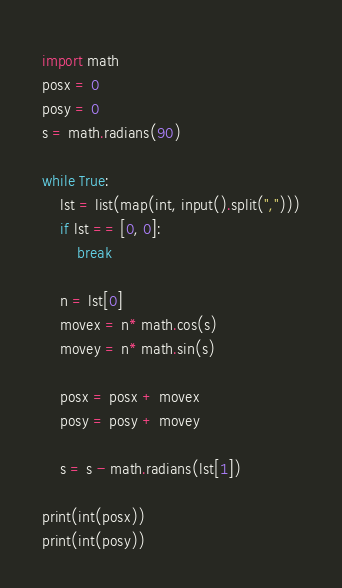<code> <loc_0><loc_0><loc_500><loc_500><_Python_>import math
posx = 0
posy = 0
s = math.radians(90)

while True:
    lst = list(map(int, input().split(",")))
    if lst == [0, 0]:
        break
    
    n = lst[0]
    movex = n* math.cos(s)
    movey = n* math.sin(s)

    posx = posx + movex
    posy = posy + movey

    s = s - math.radians(lst[1])

print(int(posx))
print(int(posy))
</code> 